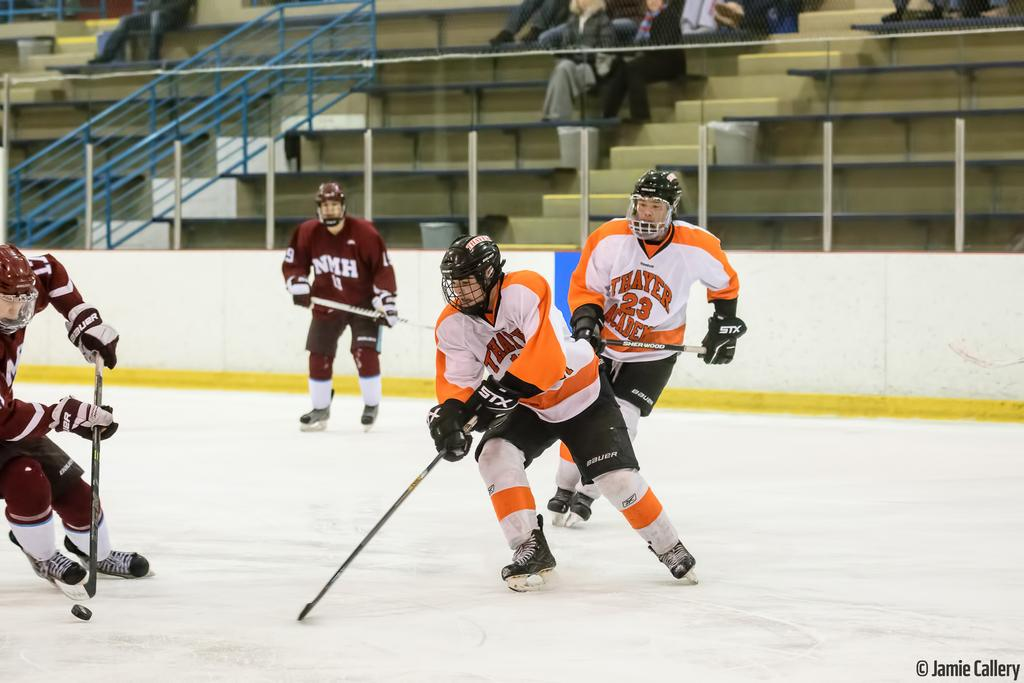What sport are the people playing in the image? The people are playing hockey in the image. What protective gear are the players wearing? The people are wearing helmets in the image. What can be seen in the background of the image? There are stands in the background of the image. What is written at the bottom of the image? There is text at the bottom of the image. What day of the week is it in the image? The day of the week is not mentioned or depicted in the image. Who is the father of the person playing hockey in the image? There is no information about the players' family members in the image. 